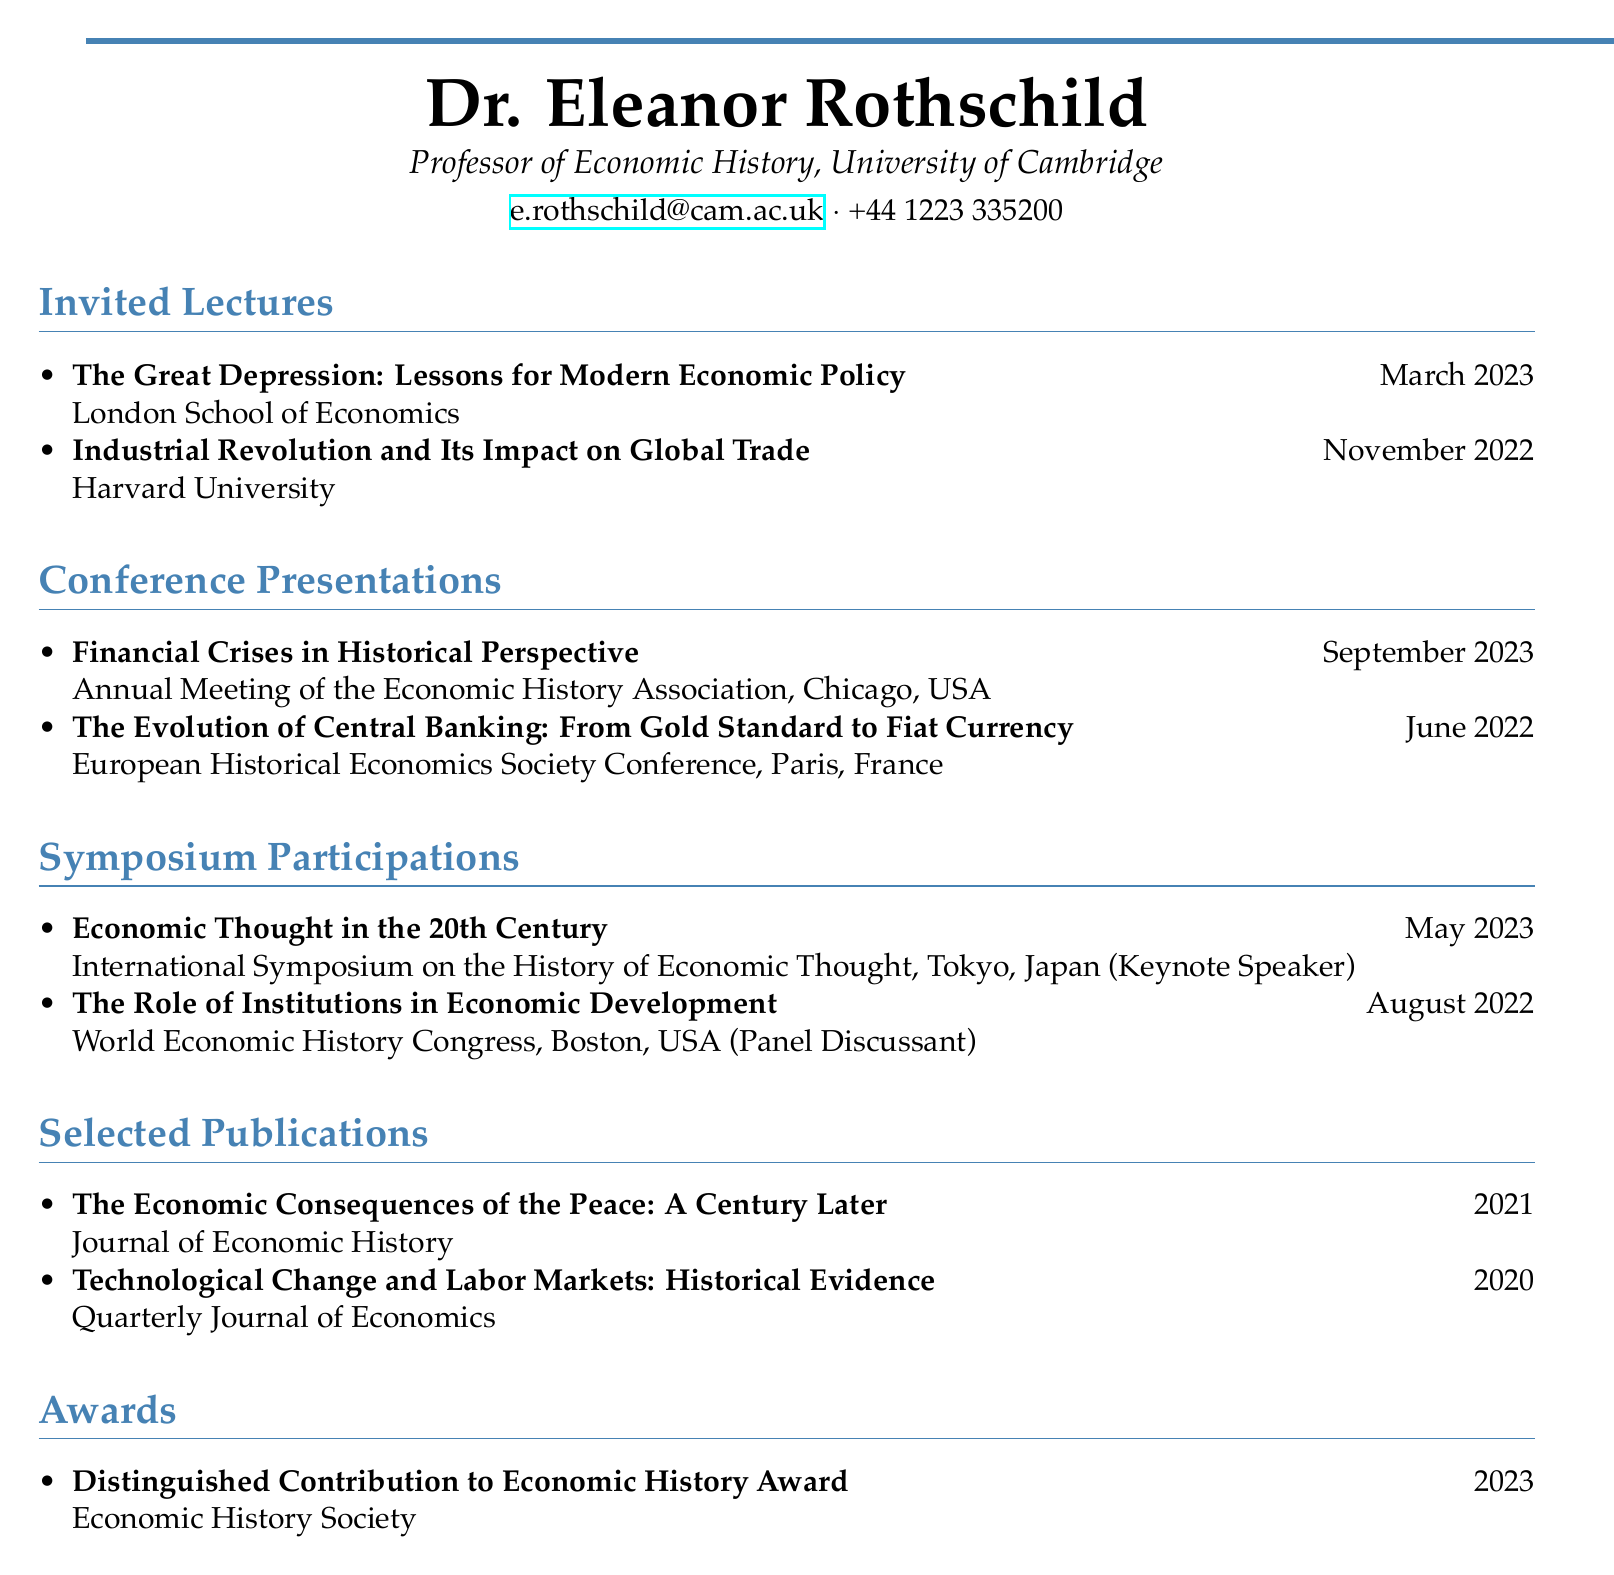What is the name of the professor? The professor's name listed in the document is found in the personal information section.
Answer: Dr. Eleanor Rothschild What university is Dr. Rothschild affiliated with? The institution where Dr. Rothschild works is specified in the personal information section.
Answer: University of Cambridge When did Dr. Rothschild give the invited lecture on "The Great Depression"? The date of that specific invited lecture is provided in the invited lectures section.
Answer: March 2023 Which event did Dr. Rothschild present at in June 2022? The conference presentation title and date can be found in the conference presentations section.
Answer: European Historical Economics Society Conference What was Dr. Rothschild's role at the International Symposium on the History of Economic Thought? The document specifies the role of Dr. Rothschild in that specific symposium in the symposium participations section.
Answer: Keynote Speaker How many invited lectures are listed in the document? The count of invited lectures can be derived from the items in the invited lectures section.
Answer: 2 What award did Dr. Rothschild receive in 2023? The award name is provided in the awards section of the document.
Answer: Distinguished Contribution to Economic History Award Where did the World Economic History Congress take place? The location of the congress is mentioned in the symposium participations section.
Answer: Boston, USA How many conference presentations are mentioned? The total number of presentations listed can be counted in the conference presentations section.
Answer: 2 